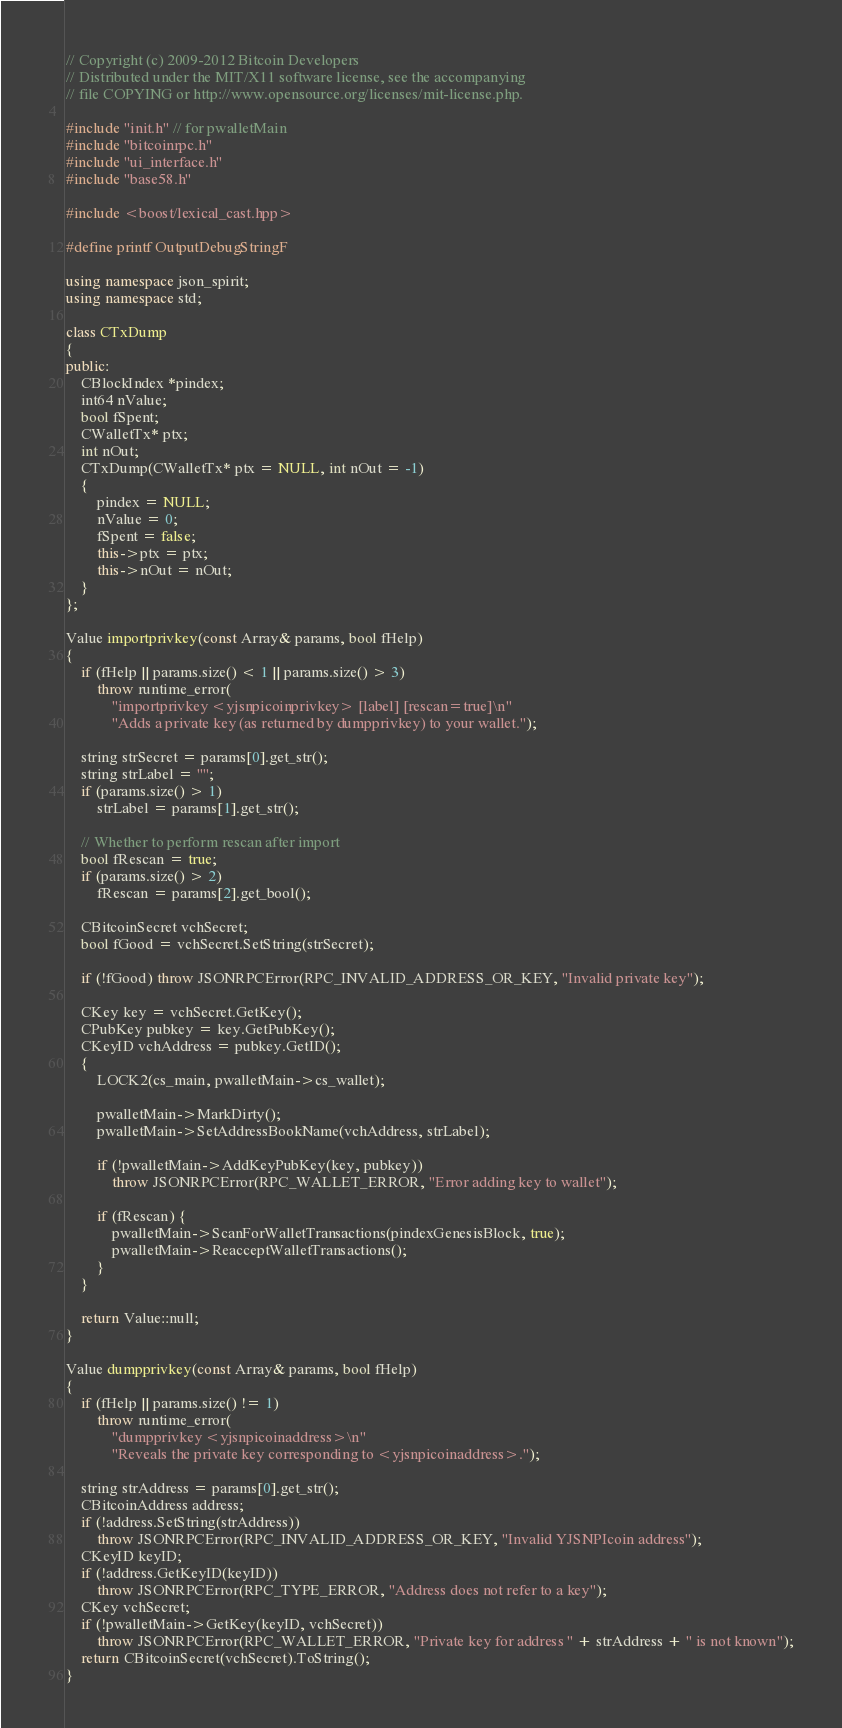<code> <loc_0><loc_0><loc_500><loc_500><_C++_>// Copyright (c) 2009-2012 Bitcoin Developers
// Distributed under the MIT/X11 software license, see the accompanying
// file COPYING or http://www.opensource.org/licenses/mit-license.php.

#include "init.h" // for pwalletMain
#include "bitcoinrpc.h"
#include "ui_interface.h"
#include "base58.h"

#include <boost/lexical_cast.hpp>

#define printf OutputDebugStringF

using namespace json_spirit;
using namespace std;

class CTxDump
{
public:
    CBlockIndex *pindex;
    int64 nValue;
    bool fSpent;
    CWalletTx* ptx;
    int nOut;
    CTxDump(CWalletTx* ptx = NULL, int nOut = -1)
    {
        pindex = NULL;
        nValue = 0;
        fSpent = false;
        this->ptx = ptx;
        this->nOut = nOut;
    }
};

Value importprivkey(const Array& params, bool fHelp)
{
    if (fHelp || params.size() < 1 || params.size() > 3)
        throw runtime_error(
            "importprivkey <yjsnpicoinprivkey> [label] [rescan=true]\n"
            "Adds a private key (as returned by dumpprivkey) to your wallet.");

    string strSecret = params[0].get_str();
    string strLabel = "";
    if (params.size() > 1)
        strLabel = params[1].get_str();

    // Whether to perform rescan after import
    bool fRescan = true;
    if (params.size() > 2)
        fRescan = params[2].get_bool();

    CBitcoinSecret vchSecret;
    bool fGood = vchSecret.SetString(strSecret);

    if (!fGood) throw JSONRPCError(RPC_INVALID_ADDRESS_OR_KEY, "Invalid private key");

    CKey key = vchSecret.GetKey();
    CPubKey pubkey = key.GetPubKey();
    CKeyID vchAddress = pubkey.GetID();
    {
        LOCK2(cs_main, pwalletMain->cs_wallet);

        pwalletMain->MarkDirty();
        pwalletMain->SetAddressBookName(vchAddress, strLabel);

        if (!pwalletMain->AddKeyPubKey(key, pubkey))
            throw JSONRPCError(RPC_WALLET_ERROR, "Error adding key to wallet");

        if (fRescan) {
            pwalletMain->ScanForWalletTransactions(pindexGenesisBlock, true);
            pwalletMain->ReacceptWalletTransactions();
        }
    }

    return Value::null;
}

Value dumpprivkey(const Array& params, bool fHelp)
{
    if (fHelp || params.size() != 1)
        throw runtime_error(
            "dumpprivkey <yjsnpicoinaddress>\n"
            "Reveals the private key corresponding to <yjsnpicoinaddress>.");

    string strAddress = params[0].get_str();
    CBitcoinAddress address;
    if (!address.SetString(strAddress))
        throw JSONRPCError(RPC_INVALID_ADDRESS_OR_KEY, "Invalid YJSNPIcoin address");
    CKeyID keyID;
    if (!address.GetKeyID(keyID))
        throw JSONRPCError(RPC_TYPE_ERROR, "Address does not refer to a key");
    CKey vchSecret;
    if (!pwalletMain->GetKey(keyID, vchSecret))
        throw JSONRPCError(RPC_WALLET_ERROR, "Private key for address " + strAddress + " is not known");
    return CBitcoinSecret(vchSecret).ToString();
}
</code> 